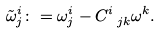Convert formula to latex. <formula><loc_0><loc_0><loc_500><loc_500>\tilde { \omega } ^ { i } _ { j } \colon = \omega ^ { i } _ { j } - C ^ { i } _ { \ j k } \omega ^ { k } .</formula> 